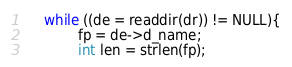Convert code to text. <code><loc_0><loc_0><loc_500><loc_500><_C_>    while ((de = readdir(dr)) != NULL){
            fp = de->d_name;
            int len = strlen(fp);</code> 